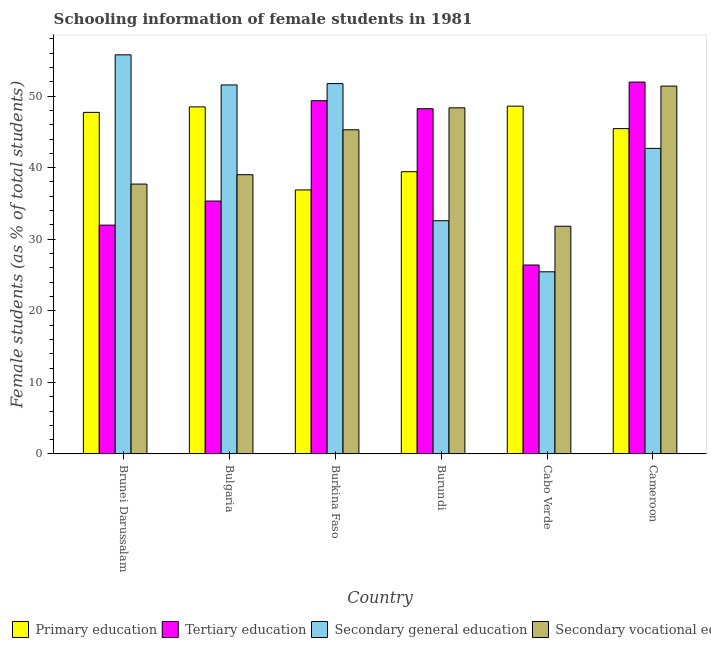How many different coloured bars are there?
Make the answer very short. 4. How many groups of bars are there?
Give a very brief answer. 6. Are the number of bars per tick equal to the number of legend labels?
Keep it short and to the point. Yes. Are the number of bars on each tick of the X-axis equal?
Make the answer very short. Yes. What is the label of the 6th group of bars from the left?
Your response must be concise. Cameroon. In how many cases, is the number of bars for a given country not equal to the number of legend labels?
Your response must be concise. 0. What is the percentage of female students in primary education in Burundi?
Give a very brief answer. 39.44. Across all countries, what is the maximum percentage of female students in secondary vocational education?
Ensure brevity in your answer.  51.4. Across all countries, what is the minimum percentage of female students in tertiary education?
Your response must be concise. 26.4. In which country was the percentage of female students in secondary education maximum?
Keep it short and to the point. Brunei Darussalam. In which country was the percentage of female students in secondary education minimum?
Your answer should be very brief. Cabo Verde. What is the total percentage of female students in secondary vocational education in the graph?
Your answer should be compact. 253.61. What is the difference between the percentage of female students in primary education in Bulgaria and that in Cabo Verde?
Your answer should be compact. -0.1. What is the difference between the percentage of female students in primary education in Brunei Darussalam and the percentage of female students in secondary education in Bulgaria?
Provide a succinct answer. -3.83. What is the average percentage of female students in secondary education per country?
Ensure brevity in your answer.  43.3. What is the difference between the percentage of female students in primary education and percentage of female students in tertiary education in Brunei Darussalam?
Your answer should be compact. 15.76. What is the ratio of the percentage of female students in secondary education in Bulgaria to that in Cabo Verde?
Your response must be concise. 2.03. Is the percentage of female students in secondary education in Burundi less than that in Cabo Verde?
Your response must be concise. No. Is the difference between the percentage of female students in secondary education in Bulgaria and Cabo Verde greater than the difference between the percentage of female students in tertiary education in Bulgaria and Cabo Verde?
Offer a terse response. Yes. What is the difference between the highest and the second highest percentage of female students in tertiary education?
Give a very brief answer. 2.6. What is the difference between the highest and the lowest percentage of female students in secondary vocational education?
Your answer should be compact. 19.58. Is the sum of the percentage of female students in secondary vocational education in Bulgaria and Cabo Verde greater than the maximum percentage of female students in tertiary education across all countries?
Give a very brief answer. Yes. What does the 3rd bar from the left in Cabo Verde represents?
Offer a terse response. Secondary general education. What does the 3rd bar from the right in Burundi represents?
Offer a very short reply. Tertiary education. Is it the case that in every country, the sum of the percentage of female students in primary education and percentage of female students in tertiary education is greater than the percentage of female students in secondary education?
Offer a very short reply. Yes. Are all the bars in the graph horizontal?
Provide a short and direct response. No. Does the graph contain any zero values?
Your answer should be very brief. No. Does the graph contain grids?
Make the answer very short. No. How many legend labels are there?
Give a very brief answer. 4. What is the title of the graph?
Give a very brief answer. Schooling information of female students in 1981. Does "Secondary general" appear as one of the legend labels in the graph?
Your answer should be very brief. No. What is the label or title of the Y-axis?
Provide a succinct answer. Female students (as % of total students). What is the Female students (as % of total students) in Primary education in Brunei Darussalam?
Your answer should be very brief. 47.73. What is the Female students (as % of total students) of Tertiary education in Brunei Darussalam?
Your answer should be compact. 31.97. What is the Female students (as % of total students) in Secondary general education in Brunei Darussalam?
Offer a terse response. 55.77. What is the Female students (as % of total students) of Secondary vocational education in Brunei Darussalam?
Make the answer very short. 37.71. What is the Female students (as % of total students) of Primary education in Bulgaria?
Offer a very short reply. 48.5. What is the Female students (as % of total students) in Tertiary education in Bulgaria?
Provide a short and direct response. 35.34. What is the Female students (as % of total students) of Secondary general education in Bulgaria?
Provide a short and direct response. 51.56. What is the Female students (as % of total students) in Secondary vocational education in Bulgaria?
Your response must be concise. 39.02. What is the Female students (as % of total students) of Primary education in Burkina Faso?
Keep it short and to the point. 36.89. What is the Female students (as % of total students) of Tertiary education in Burkina Faso?
Provide a short and direct response. 49.36. What is the Female students (as % of total students) of Secondary general education in Burkina Faso?
Offer a very short reply. 51.75. What is the Female students (as % of total students) of Secondary vocational education in Burkina Faso?
Your answer should be compact. 45.29. What is the Female students (as % of total students) in Primary education in Burundi?
Provide a short and direct response. 39.44. What is the Female students (as % of total students) of Tertiary education in Burundi?
Ensure brevity in your answer.  48.24. What is the Female students (as % of total students) of Secondary general education in Burundi?
Make the answer very short. 32.59. What is the Female students (as % of total students) in Secondary vocational education in Burundi?
Provide a succinct answer. 48.36. What is the Female students (as % of total students) of Primary education in Cabo Verde?
Ensure brevity in your answer.  48.6. What is the Female students (as % of total students) in Tertiary education in Cabo Verde?
Your response must be concise. 26.4. What is the Female students (as % of total students) in Secondary general education in Cabo Verde?
Your response must be concise. 25.45. What is the Female students (as % of total students) in Secondary vocational education in Cabo Verde?
Offer a very short reply. 31.82. What is the Female students (as % of total students) in Primary education in Cameroon?
Ensure brevity in your answer.  45.46. What is the Female students (as % of total students) in Tertiary education in Cameroon?
Offer a very short reply. 51.96. What is the Female students (as % of total students) of Secondary general education in Cameroon?
Keep it short and to the point. 42.7. What is the Female students (as % of total students) of Secondary vocational education in Cameroon?
Offer a terse response. 51.4. Across all countries, what is the maximum Female students (as % of total students) of Primary education?
Offer a very short reply. 48.6. Across all countries, what is the maximum Female students (as % of total students) of Tertiary education?
Offer a very short reply. 51.96. Across all countries, what is the maximum Female students (as % of total students) in Secondary general education?
Provide a short and direct response. 55.77. Across all countries, what is the maximum Female students (as % of total students) of Secondary vocational education?
Provide a succinct answer. 51.4. Across all countries, what is the minimum Female students (as % of total students) in Primary education?
Make the answer very short. 36.89. Across all countries, what is the minimum Female students (as % of total students) in Tertiary education?
Ensure brevity in your answer.  26.4. Across all countries, what is the minimum Female students (as % of total students) of Secondary general education?
Your answer should be compact. 25.45. Across all countries, what is the minimum Female students (as % of total students) of Secondary vocational education?
Provide a short and direct response. 31.82. What is the total Female students (as % of total students) in Primary education in the graph?
Your answer should be very brief. 266.61. What is the total Female students (as % of total students) of Tertiary education in the graph?
Make the answer very short. 243.27. What is the total Female students (as % of total students) of Secondary general education in the graph?
Give a very brief answer. 259.82. What is the total Female students (as % of total students) of Secondary vocational education in the graph?
Keep it short and to the point. 253.61. What is the difference between the Female students (as % of total students) of Primary education in Brunei Darussalam and that in Bulgaria?
Your response must be concise. -0.77. What is the difference between the Female students (as % of total students) of Tertiary education in Brunei Darussalam and that in Bulgaria?
Your answer should be compact. -3.36. What is the difference between the Female students (as % of total students) in Secondary general education in Brunei Darussalam and that in Bulgaria?
Provide a succinct answer. 4.21. What is the difference between the Female students (as % of total students) in Secondary vocational education in Brunei Darussalam and that in Bulgaria?
Ensure brevity in your answer.  -1.31. What is the difference between the Female students (as % of total students) of Primary education in Brunei Darussalam and that in Burkina Faso?
Give a very brief answer. 10.84. What is the difference between the Female students (as % of total students) in Tertiary education in Brunei Darussalam and that in Burkina Faso?
Keep it short and to the point. -17.39. What is the difference between the Female students (as % of total students) in Secondary general education in Brunei Darussalam and that in Burkina Faso?
Provide a succinct answer. 4.02. What is the difference between the Female students (as % of total students) of Secondary vocational education in Brunei Darussalam and that in Burkina Faso?
Offer a very short reply. -7.58. What is the difference between the Female students (as % of total students) of Primary education in Brunei Darussalam and that in Burundi?
Your response must be concise. 8.29. What is the difference between the Female students (as % of total students) in Tertiary education in Brunei Darussalam and that in Burundi?
Provide a short and direct response. -16.27. What is the difference between the Female students (as % of total students) of Secondary general education in Brunei Darussalam and that in Burundi?
Ensure brevity in your answer.  23.18. What is the difference between the Female students (as % of total students) in Secondary vocational education in Brunei Darussalam and that in Burundi?
Your answer should be compact. -10.65. What is the difference between the Female students (as % of total students) of Primary education in Brunei Darussalam and that in Cabo Verde?
Provide a succinct answer. -0.87. What is the difference between the Female students (as % of total students) of Tertiary education in Brunei Darussalam and that in Cabo Verde?
Your answer should be very brief. 5.57. What is the difference between the Female students (as % of total students) in Secondary general education in Brunei Darussalam and that in Cabo Verde?
Provide a succinct answer. 30.32. What is the difference between the Female students (as % of total students) of Secondary vocational education in Brunei Darussalam and that in Cabo Verde?
Your answer should be very brief. 5.89. What is the difference between the Female students (as % of total students) of Primary education in Brunei Darussalam and that in Cameroon?
Offer a terse response. 2.27. What is the difference between the Female students (as % of total students) in Tertiary education in Brunei Darussalam and that in Cameroon?
Ensure brevity in your answer.  -19.99. What is the difference between the Female students (as % of total students) in Secondary general education in Brunei Darussalam and that in Cameroon?
Your answer should be compact. 13.07. What is the difference between the Female students (as % of total students) of Secondary vocational education in Brunei Darussalam and that in Cameroon?
Provide a succinct answer. -13.69. What is the difference between the Female students (as % of total students) of Primary education in Bulgaria and that in Burkina Faso?
Keep it short and to the point. 11.61. What is the difference between the Female students (as % of total students) of Tertiary education in Bulgaria and that in Burkina Faso?
Offer a terse response. -14.02. What is the difference between the Female students (as % of total students) of Secondary general education in Bulgaria and that in Burkina Faso?
Give a very brief answer. -0.19. What is the difference between the Female students (as % of total students) of Secondary vocational education in Bulgaria and that in Burkina Faso?
Provide a succinct answer. -6.27. What is the difference between the Female students (as % of total students) of Primary education in Bulgaria and that in Burundi?
Make the answer very short. 9.06. What is the difference between the Female students (as % of total students) of Tertiary education in Bulgaria and that in Burundi?
Your answer should be compact. -12.9. What is the difference between the Female students (as % of total students) of Secondary general education in Bulgaria and that in Burundi?
Offer a terse response. 18.97. What is the difference between the Female students (as % of total students) in Secondary vocational education in Bulgaria and that in Burundi?
Provide a short and direct response. -9.34. What is the difference between the Female students (as % of total students) of Primary education in Bulgaria and that in Cabo Verde?
Offer a terse response. -0.1. What is the difference between the Female students (as % of total students) of Tertiary education in Bulgaria and that in Cabo Verde?
Your response must be concise. 8.94. What is the difference between the Female students (as % of total students) of Secondary general education in Bulgaria and that in Cabo Verde?
Your response must be concise. 26.11. What is the difference between the Female students (as % of total students) of Secondary vocational education in Bulgaria and that in Cabo Verde?
Your answer should be compact. 7.2. What is the difference between the Female students (as % of total students) of Primary education in Bulgaria and that in Cameroon?
Make the answer very short. 3.04. What is the difference between the Female students (as % of total students) of Tertiary education in Bulgaria and that in Cameroon?
Your answer should be very brief. -16.62. What is the difference between the Female students (as % of total students) of Secondary general education in Bulgaria and that in Cameroon?
Provide a succinct answer. 8.86. What is the difference between the Female students (as % of total students) of Secondary vocational education in Bulgaria and that in Cameroon?
Make the answer very short. -12.38. What is the difference between the Female students (as % of total students) in Primary education in Burkina Faso and that in Burundi?
Offer a very short reply. -2.55. What is the difference between the Female students (as % of total students) of Tertiary education in Burkina Faso and that in Burundi?
Make the answer very short. 1.12. What is the difference between the Female students (as % of total students) of Secondary general education in Burkina Faso and that in Burundi?
Provide a succinct answer. 19.16. What is the difference between the Female students (as % of total students) of Secondary vocational education in Burkina Faso and that in Burundi?
Make the answer very short. -3.07. What is the difference between the Female students (as % of total students) in Primary education in Burkina Faso and that in Cabo Verde?
Provide a short and direct response. -11.71. What is the difference between the Female students (as % of total students) in Tertiary education in Burkina Faso and that in Cabo Verde?
Ensure brevity in your answer.  22.96. What is the difference between the Female students (as % of total students) of Secondary general education in Burkina Faso and that in Cabo Verde?
Your answer should be compact. 26.3. What is the difference between the Female students (as % of total students) in Secondary vocational education in Burkina Faso and that in Cabo Verde?
Your response must be concise. 13.47. What is the difference between the Female students (as % of total students) in Primary education in Burkina Faso and that in Cameroon?
Your answer should be compact. -8.57. What is the difference between the Female students (as % of total students) of Tertiary education in Burkina Faso and that in Cameroon?
Give a very brief answer. -2.6. What is the difference between the Female students (as % of total students) of Secondary general education in Burkina Faso and that in Cameroon?
Your response must be concise. 9.05. What is the difference between the Female students (as % of total students) of Secondary vocational education in Burkina Faso and that in Cameroon?
Provide a succinct answer. -6.11. What is the difference between the Female students (as % of total students) in Primary education in Burundi and that in Cabo Verde?
Keep it short and to the point. -9.16. What is the difference between the Female students (as % of total students) of Tertiary education in Burundi and that in Cabo Verde?
Provide a short and direct response. 21.84. What is the difference between the Female students (as % of total students) in Secondary general education in Burundi and that in Cabo Verde?
Ensure brevity in your answer.  7.14. What is the difference between the Female students (as % of total students) in Secondary vocational education in Burundi and that in Cabo Verde?
Give a very brief answer. 16.54. What is the difference between the Female students (as % of total students) in Primary education in Burundi and that in Cameroon?
Offer a very short reply. -6.02. What is the difference between the Female students (as % of total students) in Tertiary education in Burundi and that in Cameroon?
Give a very brief answer. -3.72. What is the difference between the Female students (as % of total students) of Secondary general education in Burundi and that in Cameroon?
Give a very brief answer. -10.11. What is the difference between the Female students (as % of total students) in Secondary vocational education in Burundi and that in Cameroon?
Provide a succinct answer. -3.04. What is the difference between the Female students (as % of total students) in Primary education in Cabo Verde and that in Cameroon?
Give a very brief answer. 3.14. What is the difference between the Female students (as % of total students) of Tertiary education in Cabo Verde and that in Cameroon?
Offer a very short reply. -25.56. What is the difference between the Female students (as % of total students) in Secondary general education in Cabo Verde and that in Cameroon?
Keep it short and to the point. -17.25. What is the difference between the Female students (as % of total students) of Secondary vocational education in Cabo Verde and that in Cameroon?
Ensure brevity in your answer.  -19.58. What is the difference between the Female students (as % of total students) in Primary education in Brunei Darussalam and the Female students (as % of total students) in Tertiary education in Bulgaria?
Provide a succinct answer. 12.39. What is the difference between the Female students (as % of total students) of Primary education in Brunei Darussalam and the Female students (as % of total students) of Secondary general education in Bulgaria?
Your answer should be compact. -3.83. What is the difference between the Female students (as % of total students) in Primary education in Brunei Darussalam and the Female students (as % of total students) in Secondary vocational education in Bulgaria?
Your answer should be compact. 8.71. What is the difference between the Female students (as % of total students) of Tertiary education in Brunei Darussalam and the Female students (as % of total students) of Secondary general education in Bulgaria?
Give a very brief answer. -19.59. What is the difference between the Female students (as % of total students) of Tertiary education in Brunei Darussalam and the Female students (as % of total students) of Secondary vocational education in Bulgaria?
Keep it short and to the point. -7.05. What is the difference between the Female students (as % of total students) of Secondary general education in Brunei Darussalam and the Female students (as % of total students) of Secondary vocational education in Bulgaria?
Offer a very short reply. 16.75. What is the difference between the Female students (as % of total students) of Primary education in Brunei Darussalam and the Female students (as % of total students) of Tertiary education in Burkina Faso?
Keep it short and to the point. -1.63. What is the difference between the Female students (as % of total students) of Primary education in Brunei Darussalam and the Female students (as % of total students) of Secondary general education in Burkina Faso?
Ensure brevity in your answer.  -4.02. What is the difference between the Female students (as % of total students) in Primary education in Brunei Darussalam and the Female students (as % of total students) in Secondary vocational education in Burkina Faso?
Your answer should be compact. 2.43. What is the difference between the Female students (as % of total students) in Tertiary education in Brunei Darussalam and the Female students (as % of total students) in Secondary general education in Burkina Faso?
Give a very brief answer. -19.78. What is the difference between the Female students (as % of total students) of Tertiary education in Brunei Darussalam and the Female students (as % of total students) of Secondary vocational education in Burkina Faso?
Keep it short and to the point. -13.32. What is the difference between the Female students (as % of total students) of Secondary general education in Brunei Darussalam and the Female students (as % of total students) of Secondary vocational education in Burkina Faso?
Your answer should be very brief. 10.47. What is the difference between the Female students (as % of total students) of Primary education in Brunei Darussalam and the Female students (as % of total students) of Tertiary education in Burundi?
Offer a very short reply. -0.51. What is the difference between the Female students (as % of total students) of Primary education in Brunei Darussalam and the Female students (as % of total students) of Secondary general education in Burundi?
Keep it short and to the point. 15.14. What is the difference between the Female students (as % of total students) in Primary education in Brunei Darussalam and the Female students (as % of total students) in Secondary vocational education in Burundi?
Your answer should be compact. -0.63. What is the difference between the Female students (as % of total students) of Tertiary education in Brunei Darussalam and the Female students (as % of total students) of Secondary general education in Burundi?
Make the answer very short. -0.61. What is the difference between the Female students (as % of total students) in Tertiary education in Brunei Darussalam and the Female students (as % of total students) in Secondary vocational education in Burundi?
Keep it short and to the point. -16.39. What is the difference between the Female students (as % of total students) of Secondary general education in Brunei Darussalam and the Female students (as % of total students) of Secondary vocational education in Burundi?
Your answer should be very brief. 7.4. What is the difference between the Female students (as % of total students) in Primary education in Brunei Darussalam and the Female students (as % of total students) in Tertiary education in Cabo Verde?
Offer a very short reply. 21.33. What is the difference between the Female students (as % of total students) in Primary education in Brunei Darussalam and the Female students (as % of total students) in Secondary general education in Cabo Verde?
Make the answer very short. 22.28. What is the difference between the Female students (as % of total students) of Primary education in Brunei Darussalam and the Female students (as % of total students) of Secondary vocational education in Cabo Verde?
Your answer should be very brief. 15.91. What is the difference between the Female students (as % of total students) of Tertiary education in Brunei Darussalam and the Female students (as % of total students) of Secondary general education in Cabo Verde?
Keep it short and to the point. 6.52. What is the difference between the Female students (as % of total students) of Tertiary education in Brunei Darussalam and the Female students (as % of total students) of Secondary vocational education in Cabo Verde?
Your answer should be compact. 0.15. What is the difference between the Female students (as % of total students) in Secondary general education in Brunei Darussalam and the Female students (as % of total students) in Secondary vocational education in Cabo Verde?
Your response must be concise. 23.95. What is the difference between the Female students (as % of total students) of Primary education in Brunei Darussalam and the Female students (as % of total students) of Tertiary education in Cameroon?
Your response must be concise. -4.23. What is the difference between the Female students (as % of total students) of Primary education in Brunei Darussalam and the Female students (as % of total students) of Secondary general education in Cameroon?
Keep it short and to the point. 5.03. What is the difference between the Female students (as % of total students) of Primary education in Brunei Darussalam and the Female students (as % of total students) of Secondary vocational education in Cameroon?
Your answer should be compact. -3.67. What is the difference between the Female students (as % of total students) of Tertiary education in Brunei Darussalam and the Female students (as % of total students) of Secondary general education in Cameroon?
Provide a succinct answer. -10.73. What is the difference between the Female students (as % of total students) of Tertiary education in Brunei Darussalam and the Female students (as % of total students) of Secondary vocational education in Cameroon?
Give a very brief answer. -19.43. What is the difference between the Female students (as % of total students) in Secondary general education in Brunei Darussalam and the Female students (as % of total students) in Secondary vocational education in Cameroon?
Offer a very short reply. 4.37. What is the difference between the Female students (as % of total students) in Primary education in Bulgaria and the Female students (as % of total students) in Tertiary education in Burkina Faso?
Your response must be concise. -0.86. What is the difference between the Female students (as % of total students) in Primary education in Bulgaria and the Female students (as % of total students) in Secondary general education in Burkina Faso?
Provide a succinct answer. -3.26. What is the difference between the Female students (as % of total students) of Primary education in Bulgaria and the Female students (as % of total students) of Secondary vocational education in Burkina Faso?
Give a very brief answer. 3.2. What is the difference between the Female students (as % of total students) of Tertiary education in Bulgaria and the Female students (as % of total students) of Secondary general education in Burkina Faso?
Your answer should be compact. -16.42. What is the difference between the Female students (as % of total students) in Tertiary education in Bulgaria and the Female students (as % of total students) in Secondary vocational education in Burkina Faso?
Offer a very short reply. -9.96. What is the difference between the Female students (as % of total students) in Secondary general education in Bulgaria and the Female students (as % of total students) in Secondary vocational education in Burkina Faso?
Your answer should be compact. 6.27. What is the difference between the Female students (as % of total students) of Primary education in Bulgaria and the Female students (as % of total students) of Tertiary education in Burundi?
Keep it short and to the point. 0.25. What is the difference between the Female students (as % of total students) in Primary education in Bulgaria and the Female students (as % of total students) in Secondary general education in Burundi?
Provide a succinct answer. 15.91. What is the difference between the Female students (as % of total students) in Primary education in Bulgaria and the Female students (as % of total students) in Secondary vocational education in Burundi?
Your answer should be very brief. 0.13. What is the difference between the Female students (as % of total students) in Tertiary education in Bulgaria and the Female students (as % of total students) in Secondary general education in Burundi?
Offer a very short reply. 2.75. What is the difference between the Female students (as % of total students) of Tertiary education in Bulgaria and the Female students (as % of total students) of Secondary vocational education in Burundi?
Your answer should be compact. -13.03. What is the difference between the Female students (as % of total students) of Secondary general education in Bulgaria and the Female students (as % of total students) of Secondary vocational education in Burundi?
Offer a terse response. 3.2. What is the difference between the Female students (as % of total students) of Primary education in Bulgaria and the Female students (as % of total students) of Tertiary education in Cabo Verde?
Your answer should be very brief. 22.1. What is the difference between the Female students (as % of total students) of Primary education in Bulgaria and the Female students (as % of total students) of Secondary general education in Cabo Verde?
Your answer should be very brief. 23.04. What is the difference between the Female students (as % of total students) in Primary education in Bulgaria and the Female students (as % of total students) in Secondary vocational education in Cabo Verde?
Make the answer very short. 16.67. What is the difference between the Female students (as % of total students) of Tertiary education in Bulgaria and the Female students (as % of total students) of Secondary general education in Cabo Verde?
Provide a short and direct response. 9.88. What is the difference between the Female students (as % of total students) in Tertiary education in Bulgaria and the Female students (as % of total students) in Secondary vocational education in Cabo Verde?
Ensure brevity in your answer.  3.52. What is the difference between the Female students (as % of total students) in Secondary general education in Bulgaria and the Female students (as % of total students) in Secondary vocational education in Cabo Verde?
Give a very brief answer. 19.74. What is the difference between the Female students (as % of total students) of Primary education in Bulgaria and the Female students (as % of total students) of Tertiary education in Cameroon?
Your answer should be very brief. -3.47. What is the difference between the Female students (as % of total students) of Primary education in Bulgaria and the Female students (as % of total students) of Secondary general education in Cameroon?
Give a very brief answer. 5.8. What is the difference between the Female students (as % of total students) of Primary education in Bulgaria and the Female students (as % of total students) of Secondary vocational education in Cameroon?
Offer a very short reply. -2.91. What is the difference between the Female students (as % of total students) of Tertiary education in Bulgaria and the Female students (as % of total students) of Secondary general education in Cameroon?
Provide a short and direct response. -7.36. What is the difference between the Female students (as % of total students) in Tertiary education in Bulgaria and the Female students (as % of total students) in Secondary vocational education in Cameroon?
Provide a succinct answer. -16.06. What is the difference between the Female students (as % of total students) of Secondary general education in Bulgaria and the Female students (as % of total students) of Secondary vocational education in Cameroon?
Give a very brief answer. 0.16. What is the difference between the Female students (as % of total students) in Primary education in Burkina Faso and the Female students (as % of total students) in Tertiary education in Burundi?
Keep it short and to the point. -11.35. What is the difference between the Female students (as % of total students) of Primary education in Burkina Faso and the Female students (as % of total students) of Secondary general education in Burundi?
Your response must be concise. 4.3. What is the difference between the Female students (as % of total students) of Primary education in Burkina Faso and the Female students (as % of total students) of Secondary vocational education in Burundi?
Offer a very short reply. -11.47. What is the difference between the Female students (as % of total students) of Tertiary education in Burkina Faso and the Female students (as % of total students) of Secondary general education in Burundi?
Provide a succinct answer. 16.77. What is the difference between the Female students (as % of total students) in Tertiary education in Burkina Faso and the Female students (as % of total students) in Secondary vocational education in Burundi?
Offer a very short reply. 1. What is the difference between the Female students (as % of total students) of Secondary general education in Burkina Faso and the Female students (as % of total students) of Secondary vocational education in Burundi?
Keep it short and to the point. 3.39. What is the difference between the Female students (as % of total students) of Primary education in Burkina Faso and the Female students (as % of total students) of Tertiary education in Cabo Verde?
Make the answer very short. 10.49. What is the difference between the Female students (as % of total students) in Primary education in Burkina Faso and the Female students (as % of total students) in Secondary general education in Cabo Verde?
Give a very brief answer. 11.44. What is the difference between the Female students (as % of total students) of Primary education in Burkina Faso and the Female students (as % of total students) of Secondary vocational education in Cabo Verde?
Provide a succinct answer. 5.07. What is the difference between the Female students (as % of total students) in Tertiary education in Burkina Faso and the Female students (as % of total students) in Secondary general education in Cabo Verde?
Offer a very short reply. 23.91. What is the difference between the Female students (as % of total students) of Tertiary education in Burkina Faso and the Female students (as % of total students) of Secondary vocational education in Cabo Verde?
Keep it short and to the point. 17.54. What is the difference between the Female students (as % of total students) of Secondary general education in Burkina Faso and the Female students (as % of total students) of Secondary vocational education in Cabo Verde?
Give a very brief answer. 19.93. What is the difference between the Female students (as % of total students) of Primary education in Burkina Faso and the Female students (as % of total students) of Tertiary education in Cameroon?
Ensure brevity in your answer.  -15.07. What is the difference between the Female students (as % of total students) in Primary education in Burkina Faso and the Female students (as % of total students) in Secondary general education in Cameroon?
Keep it short and to the point. -5.81. What is the difference between the Female students (as % of total students) in Primary education in Burkina Faso and the Female students (as % of total students) in Secondary vocational education in Cameroon?
Your response must be concise. -14.51. What is the difference between the Female students (as % of total students) in Tertiary education in Burkina Faso and the Female students (as % of total students) in Secondary general education in Cameroon?
Your response must be concise. 6.66. What is the difference between the Female students (as % of total students) in Tertiary education in Burkina Faso and the Female students (as % of total students) in Secondary vocational education in Cameroon?
Your answer should be compact. -2.04. What is the difference between the Female students (as % of total students) in Secondary general education in Burkina Faso and the Female students (as % of total students) in Secondary vocational education in Cameroon?
Make the answer very short. 0.35. What is the difference between the Female students (as % of total students) in Primary education in Burundi and the Female students (as % of total students) in Tertiary education in Cabo Verde?
Make the answer very short. 13.04. What is the difference between the Female students (as % of total students) of Primary education in Burundi and the Female students (as % of total students) of Secondary general education in Cabo Verde?
Offer a very short reply. 13.98. What is the difference between the Female students (as % of total students) of Primary education in Burundi and the Female students (as % of total students) of Secondary vocational education in Cabo Verde?
Your answer should be very brief. 7.62. What is the difference between the Female students (as % of total students) in Tertiary education in Burundi and the Female students (as % of total students) in Secondary general education in Cabo Verde?
Provide a short and direct response. 22.79. What is the difference between the Female students (as % of total students) in Tertiary education in Burundi and the Female students (as % of total students) in Secondary vocational education in Cabo Verde?
Offer a very short reply. 16.42. What is the difference between the Female students (as % of total students) of Secondary general education in Burundi and the Female students (as % of total students) of Secondary vocational education in Cabo Verde?
Your answer should be very brief. 0.77. What is the difference between the Female students (as % of total students) of Primary education in Burundi and the Female students (as % of total students) of Tertiary education in Cameroon?
Offer a terse response. -12.52. What is the difference between the Female students (as % of total students) in Primary education in Burundi and the Female students (as % of total students) in Secondary general education in Cameroon?
Offer a terse response. -3.26. What is the difference between the Female students (as % of total students) of Primary education in Burundi and the Female students (as % of total students) of Secondary vocational education in Cameroon?
Provide a short and direct response. -11.96. What is the difference between the Female students (as % of total students) in Tertiary education in Burundi and the Female students (as % of total students) in Secondary general education in Cameroon?
Provide a short and direct response. 5.54. What is the difference between the Female students (as % of total students) of Tertiary education in Burundi and the Female students (as % of total students) of Secondary vocational education in Cameroon?
Offer a terse response. -3.16. What is the difference between the Female students (as % of total students) in Secondary general education in Burundi and the Female students (as % of total students) in Secondary vocational education in Cameroon?
Provide a short and direct response. -18.81. What is the difference between the Female students (as % of total students) of Primary education in Cabo Verde and the Female students (as % of total students) of Tertiary education in Cameroon?
Your response must be concise. -3.37. What is the difference between the Female students (as % of total students) of Primary education in Cabo Verde and the Female students (as % of total students) of Secondary general education in Cameroon?
Offer a terse response. 5.9. What is the difference between the Female students (as % of total students) of Primary education in Cabo Verde and the Female students (as % of total students) of Secondary vocational education in Cameroon?
Provide a succinct answer. -2.81. What is the difference between the Female students (as % of total students) of Tertiary education in Cabo Verde and the Female students (as % of total students) of Secondary general education in Cameroon?
Offer a terse response. -16.3. What is the difference between the Female students (as % of total students) in Tertiary education in Cabo Verde and the Female students (as % of total students) in Secondary vocational education in Cameroon?
Keep it short and to the point. -25. What is the difference between the Female students (as % of total students) in Secondary general education in Cabo Verde and the Female students (as % of total students) in Secondary vocational education in Cameroon?
Offer a terse response. -25.95. What is the average Female students (as % of total students) in Primary education per country?
Offer a very short reply. 44.43. What is the average Female students (as % of total students) of Tertiary education per country?
Your response must be concise. 40.55. What is the average Female students (as % of total students) of Secondary general education per country?
Offer a terse response. 43.3. What is the average Female students (as % of total students) in Secondary vocational education per country?
Provide a succinct answer. 42.27. What is the difference between the Female students (as % of total students) of Primary education and Female students (as % of total students) of Tertiary education in Brunei Darussalam?
Make the answer very short. 15.76. What is the difference between the Female students (as % of total students) in Primary education and Female students (as % of total students) in Secondary general education in Brunei Darussalam?
Your answer should be very brief. -8.04. What is the difference between the Female students (as % of total students) of Primary education and Female students (as % of total students) of Secondary vocational education in Brunei Darussalam?
Your answer should be compact. 10.02. What is the difference between the Female students (as % of total students) of Tertiary education and Female students (as % of total students) of Secondary general education in Brunei Darussalam?
Ensure brevity in your answer.  -23.79. What is the difference between the Female students (as % of total students) in Tertiary education and Female students (as % of total students) in Secondary vocational education in Brunei Darussalam?
Provide a succinct answer. -5.74. What is the difference between the Female students (as % of total students) in Secondary general education and Female students (as % of total students) in Secondary vocational education in Brunei Darussalam?
Give a very brief answer. 18.06. What is the difference between the Female students (as % of total students) in Primary education and Female students (as % of total students) in Tertiary education in Bulgaria?
Provide a succinct answer. 13.16. What is the difference between the Female students (as % of total students) in Primary education and Female students (as % of total students) in Secondary general education in Bulgaria?
Offer a terse response. -3.07. What is the difference between the Female students (as % of total students) in Primary education and Female students (as % of total students) in Secondary vocational education in Bulgaria?
Ensure brevity in your answer.  9.48. What is the difference between the Female students (as % of total students) in Tertiary education and Female students (as % of total students) in Secondary general education in Bulgaria?
Keep it short and to the point. -16.23. What is the difference between the Female students (as % of total students) of Tertiary education and Female students (as % of total students) of Secondary vocational education in Bulgaria?
Your response must be concise. -3.68. What is the difference between the Female students (as % of total students) of Secondary general education and Female students (as % of total students) of Secondary vocational education in Bulgaria?
Your response must be concise. 12.54. What is the difference between the Female students (as % of total students) of Primary education and Female students (as % of total students) of Tertiary education in Burkina Faso?
Keep it short and to the point. -12.47. What is the difference between the Female students (as % of total students) of Primary education and Female students (as % of total students) of Secondary general education in Burkina Faso?
Your answer should be very brief. -14.86. What is the difference between the Female students (as % of total students) of Primary education and Female students (as % of total students) of Secondary vocational education in Burkina Faso?
Your response must be concise. -8.4. What is the difference between the Female students (as % of total students) of Tertiary education and Female students (as % of total students) of Secondary general education in Burkina Faso?
Keep it short and to the point. -2.39. What is the difference between the Female students (as % of total students) in Tertiary education and Female students (as % of total students) in Secondary vocational education in Burkina Faso?
Your response must be concise. 4.06. What is the difference between the Female students (as % of total students) in Secondary general education and Female students (as % of total students) in Secondary vocational education in Burkina Faso?
Provide a succinct answer. 6.46. What is the difference between the Female students (as % of total students) of Primary education and Female students (as % of total students) of Tertiary education in Burundi?
Offer a very short reply. -8.8. What is the difference between the Female students (as % of total students) in Primary education and Female students (as % of total students) in Secondary general education in Burundi?
Your response must be concise. 6.85. What is the difference between the Female students (as % of total students) in Primary education and Female students (as % of total students) in Secondary vocational education in Burundi?
Provide a succinct answer. -8.93. What is the difference between the Female students (as % of total students) in Tertiary education and Female students (as % of total students) in Secondary general education in Burundi?
Your answer should be very brief. 15.65. What is the difference between the Female students (as % of total students) in Tertiary education and Female students (as % of total students) in Secondary vocational education in Burundi?
Make the answer very short. -0.12. What is the difference between the Female students (as % of total students) of Secondary general education and Female students (as % of total students) of Secondary vocational education in Burundi?
Provide a succinct answer. -15.78. What is the difference between the Female students (as % of total students) of Primary education and Female students (as % of total students) of Tertiary education in Cabo Verde?
Your answer should be compact. 22.2. What is the difference between the Female students (as % of total students) of Primary education and Female students (as % of total students) of Secondary general education in Cabo Verde?
Your answer should be compact. 23.14. What is the difference between the Female students (as % of total students) in Primary education and Female students (as % of total students) in Secondary vocational education in Cabo Verde?
Provide a succinct answer. 16.77. What is the difference between the Female students (as % of total students) in Tertiary education and Female students (as % of total students) in Secondary general education in Cabo Verde?
Your answer should be very brief. 0.95. What is the difference between the Female students (as % of total students) of Tertiary education and Female students (as % of total students) of Secondary vocational education in Cabo Verde?
Offer a very short reply. -5.42. What is the difference between the Female students (as % of total students) in Secondary general education and Female students (as % of total students) in Secondary vocational education in Cabo Verde?
Keep it short and to the point. -6.37. What is the difference between the Female students (as % of total students) in Primary education and Female students (as % of total students) in Tertiary education in Cameroon?
Your answer should be compact. -6.5. What is the difference between the Female students (as % of total students) of Primary education and Female students (as % of total students) of Secondary general education in Cameroon?
Keep it short and to the point. 2.76. What is the difference between the Female students (as % of total students) of Primary education and Female students (as % of total students) of Secondary vocational education in Cameroon?
Your answer should be compact. -5.94. What is the difference between the Female students (as % of total students) of Tertiary education and Female students (as % of total students) of Secondary general education in Cameroon?
Keep it short and to the point. 9.26. What is the difference between the Female students (as % of total students) of Tertiary education and Female students (as % of total students) of Secondary vocational education in Cameroon?
Your response must be concise. 0.56. What is the difference between the Female students (as % of total students) of Secondary general education and Female students (as % of total students) of Secondary vocational education in Cameroon?
Keep it short and to the point. -8.7. What is the ratio of the Female students (as % of total students) in Primary education in Brunei Darussalam to that in Bulgaria?
Provide a succinct answer. 0.98. What is the ratio of the Female students (as % of total students) in Tertiary education in Brunei Darussalam to that in Bulgaria?
Give a very brief answer. 0.9. What is the ratio of the Female students (as % of total students) of Secondary general education in Brunei Darussalam to that in Bulgaria?
Give a very brief answer. 1.08. What is the ratio of the Female students (as % of total students) in Secondary vocational education in Brunei Darussalam to that in Bulgaria?
Provide a succinct answer. 0.97. What is the ratio of the Female students (as % of total students) in Primary education in Brunei Darussalam to that in Burkina Faso?
Make the answer very short. 1.29. What is the ratio of the Female students (as % of total students) in Tertiary education in Brunei Darussalam to that in Burkina Faso?
Offer a terse response. 0.65. What is the ratio of the Female students (as % of total students) of Secondary general education in Brunei Darussalam to that in Burkina Faso?
Your response must be concise. 1.08. What is the ratio of the Female students (as % of total students) of Secondary vocational education in Brunei Darussalam to that in Burkina Faso?
Your response must be concise. 0.83. What is the ratio of the Female students (as % of total students) in Primary education in Brunei Darussalam to that in Burundi?
Your answer should be compact. 1.21. What is the ratio of the Female students (as % of total students) in Tertiary education in Brunei Darussalam to that in Burundi?
Ensure brevity in your answer.  0.66. What is the ratio of the Female students (as % of total students) of Secondary general education in Brunei Darussalam to that in Burundi?
Give a very brief answer. 1.71. What is the ratio of the Female students (as % of total students) of Secondary vocational education in Brunei Darussalam to that in Burundi?
Give a very brief answer. 0.78. What is the ratio of the Female students (as % of total students) in Primary education in Brunei Darussalam to that in Cabo Verde?
Provide a short and direct response. 0.98. What is the ratio of the Female students (as % of total students) of Tertiary education in Brunei Darussalam to that in Cabo Verde?
Give a very brief answer. 1.21. What is the ratio of the Female students (as % of total students) of Secondary general education in Brunei Darussalam to that in Cabo Verde?
Offer a very short reply. 2.19. What is the ratio of the Female students (as % of total students) in Secondary vocational education in Brunei Darussalam to that in Cabo Verde?
Give a very brief answer. 1.19. What is the ratio of the Female students (as % of total students) in Primary education in Brunei Darussalam to that in Cameroon?
Your answer should be very brief. 1.05. What is the ratio of the Female students (as % of total students) in Tertiary education in Brunei Darussalam to that in Cameroon?
Ensure brevity in your answer.  0.62. What is the ratio of the Female students (as % of total students) in Secondary general education in Brunei Darussalam to that in Cameroon?
Ensure brevity in your answer.  1.31. What is the ratio of the Female students (as % of total students) in Secondary vocational education in Brunei Darussalam to that in Cameroon?
Offer a terse response. 0.73. What is the ratio of the Female students (as % of total students) in Primary education in Bulgaria to that in Burkina Faso?
Ensure brevity in your answer.  1.31. What is the ratio of the Female students (as % of total students) in Tertiary education in Bulgaria to that in Burkina Faso?
Provide a short and direct response. 0.72. What is the ratio of the Female students (as % of total students) in Secondary vocational education in Bulgaria to that in Burkina Faso?
Your answer should be very brief. 0.86. What is the ratio of the Female students (as % of total students) of Primary education in Bulgaria to that in Burundi?
Provide a short and direct response. 1.23. What is the ratio of the Female students (as % of total students) in Tertiary education in Bulgaria to that in Burundi?
Offer a very short reply. 0.73. What is the ratio of the Female students (as % of total students) of Secondary general education in Bulgaria to that in Burundi?
Keep it short and to the point. 1.58. What is the ratio of the Female students (as % of total students) of Secondary vocational education in Bulgaria to that in Burundi?
Ensure brevity in your answer.  0.81. What is the ratio of the Female students (as % of total students) in Tertiary education in Bulgaria to that in Cabo Verde?
Keep it short and to the point. 1.34. What is the ratio of the Female students (as % of total students) in Secondary general education in Bulgaria to that in Cabo Verde?
Offer a very short reply. 2.03. What is the ratio of the Female students (as % of total students) of Secondary vocational education in Bulgaria to that in Cabo Verde?
Your answer should be compact. 1.23. What is the ratio of the Female students (as % of total students) of Primary education in Bulgaria to that in Cameroon?
Keep it short and to the point. 1.07. What is the ratio of the Female students (as % of total students) of Tertiary education in Bulgaria to that in Cameroon?
Your answer should be compact. 0.68. What is the ratio of the Female students (as % of total students) in Secondary general education in Bulgaria to that in Cameroon?
Your answer should be very brief. 1.21. What is the ratio of the Female students (as % of total students) in Secondary vocational education in Bulgaria to that in Cameroon?
Ensure brevity in your answer.  0.76. What is the ratio of the Female students (as % of total students) of Primary education in Burkina Faso to that in Burundi?
Provide a short and direct response. 0.94. What is the ratio of the Female students (as % of total students) of Tertiary education in Burkina Faso to that in Burundi?
Keep it short and to the point. 1.02. What is the ratio of the Female students (as % of total students) in Secondary general education in Burkina Faso to that in Burundi?
Give a very brief answer. 1.59. What is the ratio of the Female students (as % of total students) in Secondary vocational education in Burkina Faso to that in Burundi?
Your answer should be very brief. 0.94. What is the ratio of the Female students (as % of total students) of Primary education in Burkina Faso to that in Cabo Verde?
Offer a terse response. 0.76. What is the ratio of the Female students (as % of total students) in Tertiary education in Burkina Faso to that in Cabo Verde?
Give a very brief answer. 1.87. What is the ratio of the Female students (as % of total students) of Secondary general education in Burkina Faso to that in Cabo Verde?
Your response must be concise. 2.03. What is the ratio of the Female students (as % of total students) in Secondary vocational education in Burkina Faso to that in Cabo Verde?
Make the answer very short. 1.42. What is the ratio of the Female students (as % of total students) of Primary education in Burkina Faso to that in Cameroon?
Provide a short and direct response. 0.81. What is the ratio of the Female students (as % of total students) of Tertiary education in Burkina Faso to that in Cameroon?
Provide a succinct answer. 0.95. What is the ratio of the Female students (as % of total students) in Secondary general education in Burkina Faso to that in Cameroon?
Make the answer very short. 1.21. What is the ratio of the Female students (as % of total students) in Secondary vocational education in Burkina Faso to that in Cameroon?
Offer a very short reply. 0.88. What is the ratio of the Female students (as % of total students) of Primary education in Burundi to that in Cabo Verde?
Make the answer very short. 0.81. What is the ratio of the Female students (as % of total students) of Tertiary education in Burundi to that in Cabo Verde?
Make the answer very short. 1.83. What is the ratio of the Female students (as % of total students) of Secondary general education in Burundi to that in Cabo Verde?
Offer a terse response. 1.28. What is the ratio of the Female students (as % of total students) in Secondary vocational education in Burundi to that in Cabo Verde?
Your response must be concise. 1.52. What is the ratio of the Female students (as % of total students) of Primary education in Burundi to that in Cameroon?
Your answer should be compact. 0.87. What is the ratio of the Female students (as % of total students) in Tertiary education in Burundi to that in Cameroon?
Give a very brief answer. 0.93. What is the ratio of the Female students (as % of total students) of Secondary general education in Burundi to that in Cameroon?
Your response must be concise. 0.76. What is the ratio of the Female students (as % of total students) of Secondary vocational education in Burundi to that in Cameroon?
Make the answer very short. 0.94. What is the ratio of the Female students (as % of total students) in Primary education in Cabo Verde to that in Cameroon?
Your response must be concise. 1.07. What is the ratio of the Female students (as % of total students) in Tertiary education in Cabo Verde to that in Cameroon?
Provide a succinct answer. 0.51. What is the ratio of the Female students (as % of total students) in Secondary general education in Cabo Verde to that in Cameroon?
Your answer should be compact. 0.6. What is the ratio of the Female students (as % of total students) of Secondary vocational education in Cabo Verde to that in Cameroon?
Provide a succinct answer. 0.62. What is the difference between the highest and the second highest Female students (as % of total students) in Primary education?
Offer a terse response. 0.1. What is the difference between the highest and the second highest Female students (as % of total students) in Tertiary education?
Give a very brief answer. 2.6. What is the difference between the highest and the second highest Female students (as % of total students) of Secondary general education?
Give a very brief answer. 4.02. What is the difference between the highest and the second highest Female students (as % of total students) of Secondary vocational education?
Keep it short and to the point. 3.04. What is the difference between the highest and the lowest Female students (as % of total students) in Primary education?
Provide a short and direct response. 11.71. What is the difference between the highest and the lowest Female students (as % of total students) in Tertiary education?
Make the answer very short. 25.56. What is the difference between the highest and the lowest Female students (as % of total students) in Secondary general education?
Provide a succinct answer. 30.32. What is the difference between the highest and the lowest Female students (as % of total students) of Secondary vocational education?
Provide a succinct answer. 19.58. 